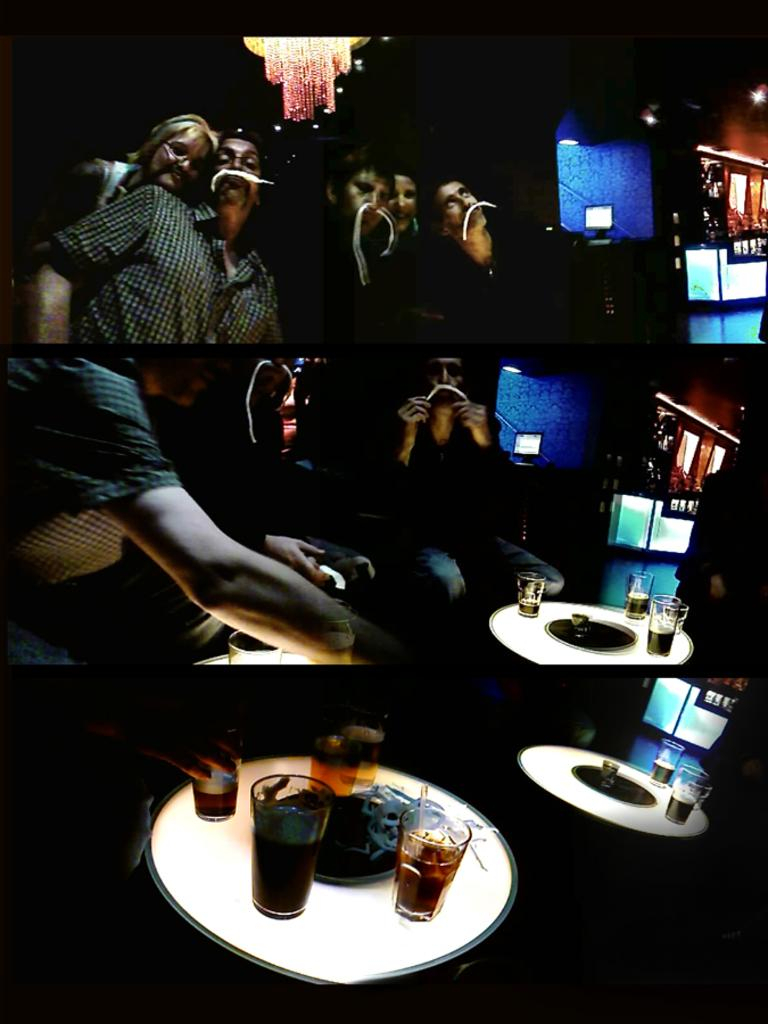What can be seen in the image in terms of people? There are people standing in the image. What type of lighting is present in the image? There is a chandelier and other lights visible in the image. What kind of structure is in the image? There is a stall in the image. What electronic device is present in the image? There is a monitor in the image. What is the background of the image made of? There is a wall in the image. What can be seen on the tables in the image? There are glasses with drinks on tables in the image. What type of oatmeal is being served in the image? There is no oatmeal present in the image. How many cups are visible on the tables in the image? There is no mention of cups in the image; only glasses with drinks are present. 